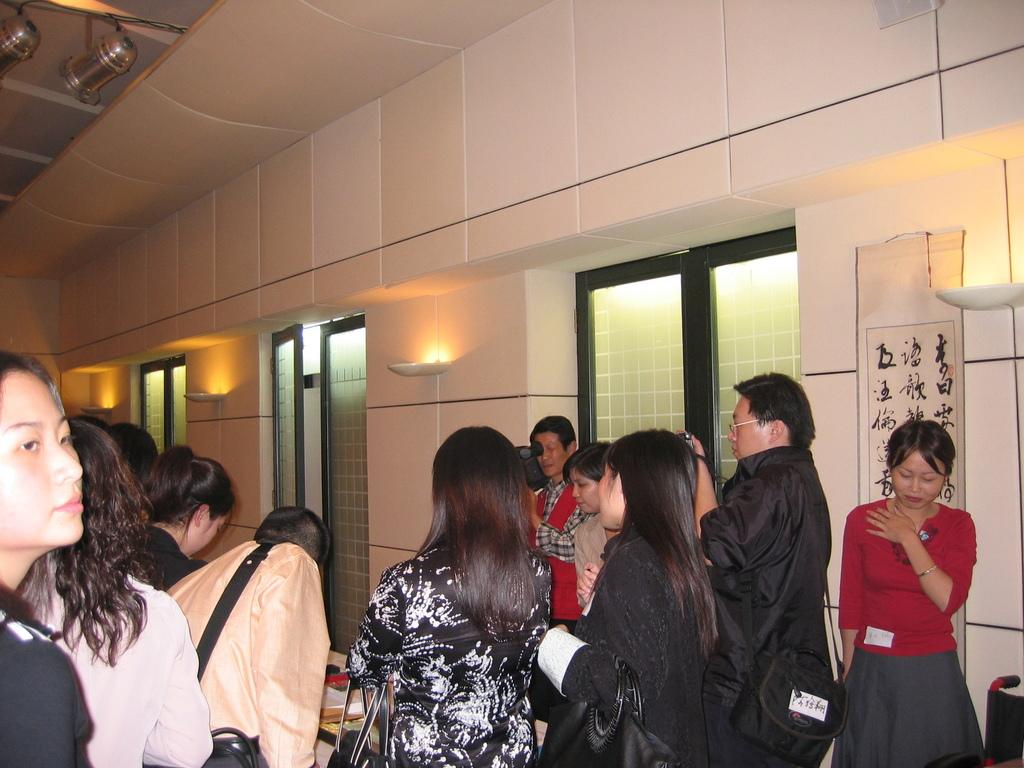How many people are in the image? There is a group of people standing in the image. What is present in the image besides the people? There is a table, a window, a light, a door, and a wall in the image. Can you describe the window in the image? There is a window in the image, but its specific features are not mentioned in the facts. What is the purpose of the light in the image? The purpose of the light in the image is not mentioned in the facts. What type of coal is visible on the table in the image? There is no coal present in the image. Is there a minister standing among the group of people in the image? The facts do not mention the presence of a minister in the image. Can you see any cobwebs in the image? The facts do not mention the presence of cobwebs in the image. 